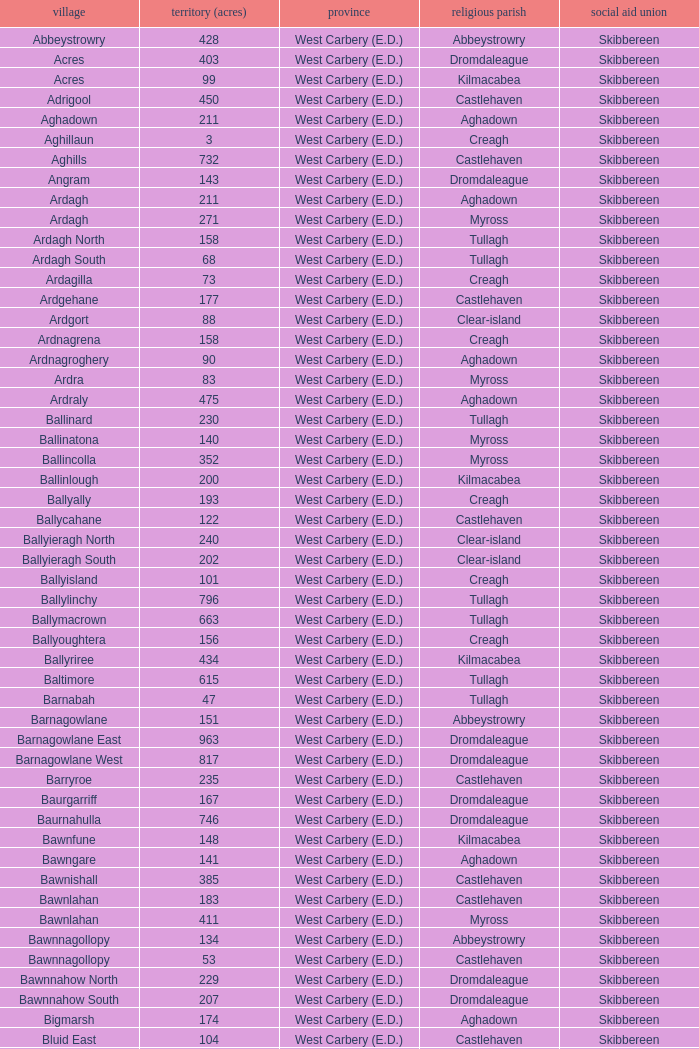What are the civil parishes of the Loughmarsh townland? Aghadown. 